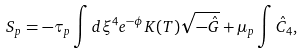<formula> <loc_0><loc_0><loc_500><loc_500>S _ { p } = - \tau _ { p } \int d \xi ^ { 4 } e ^ { - \phi } K ( T ) \sqrt { - \hat { G } } + \mu _ { p } \int \hat { C } _ { 4 } ,</formula> 